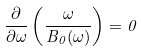<formula> <loc_0><loc_0><loc_500><loc_500>\frac { \partial } { \partial \omega } \left ( \frac { \omega } { B _ { 0 } ( \omega ) } \right ) = 0</formula> 